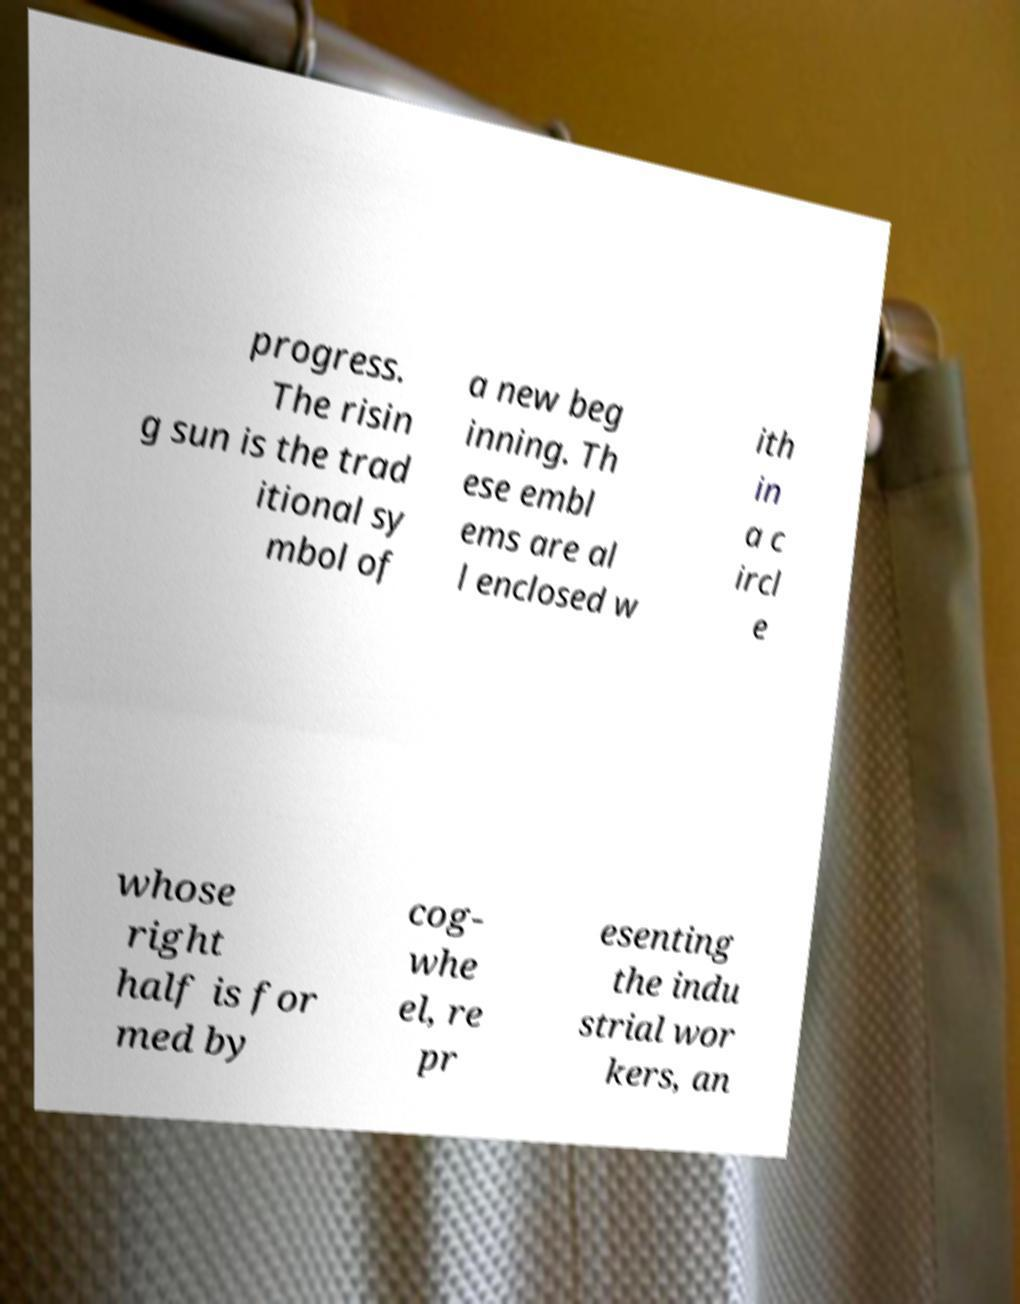For documentation purposes, I need the text within this image transcribed. Could you provide that? progress. The risin g sun is the trad itional sy mbol of a new beg inning. Th ese embl ems are al l enclosed w ith in a c ircl e whose right half is for med by cog- whe el, re pr esenting the indu strial wor kers, an 